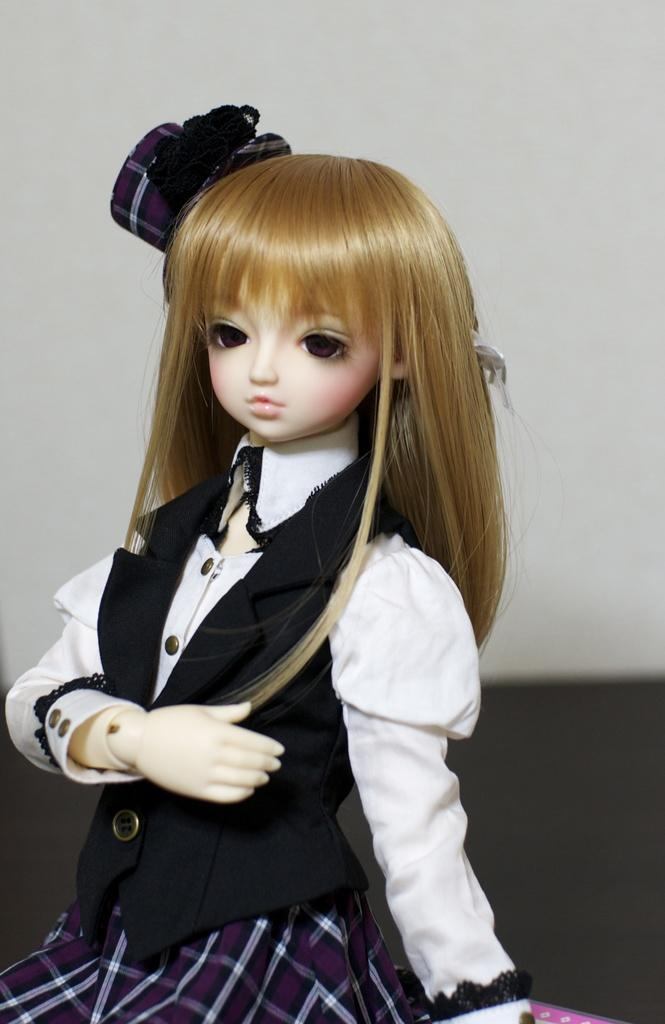What object can be seen in the image? There is a toy in the image. What colors are used in the background of the image? The background of the image is white and black in color. What type of seed is being planted by the police officer in the image? There is no police officer or seed present in the image; it only features a toy and a white and black background. 